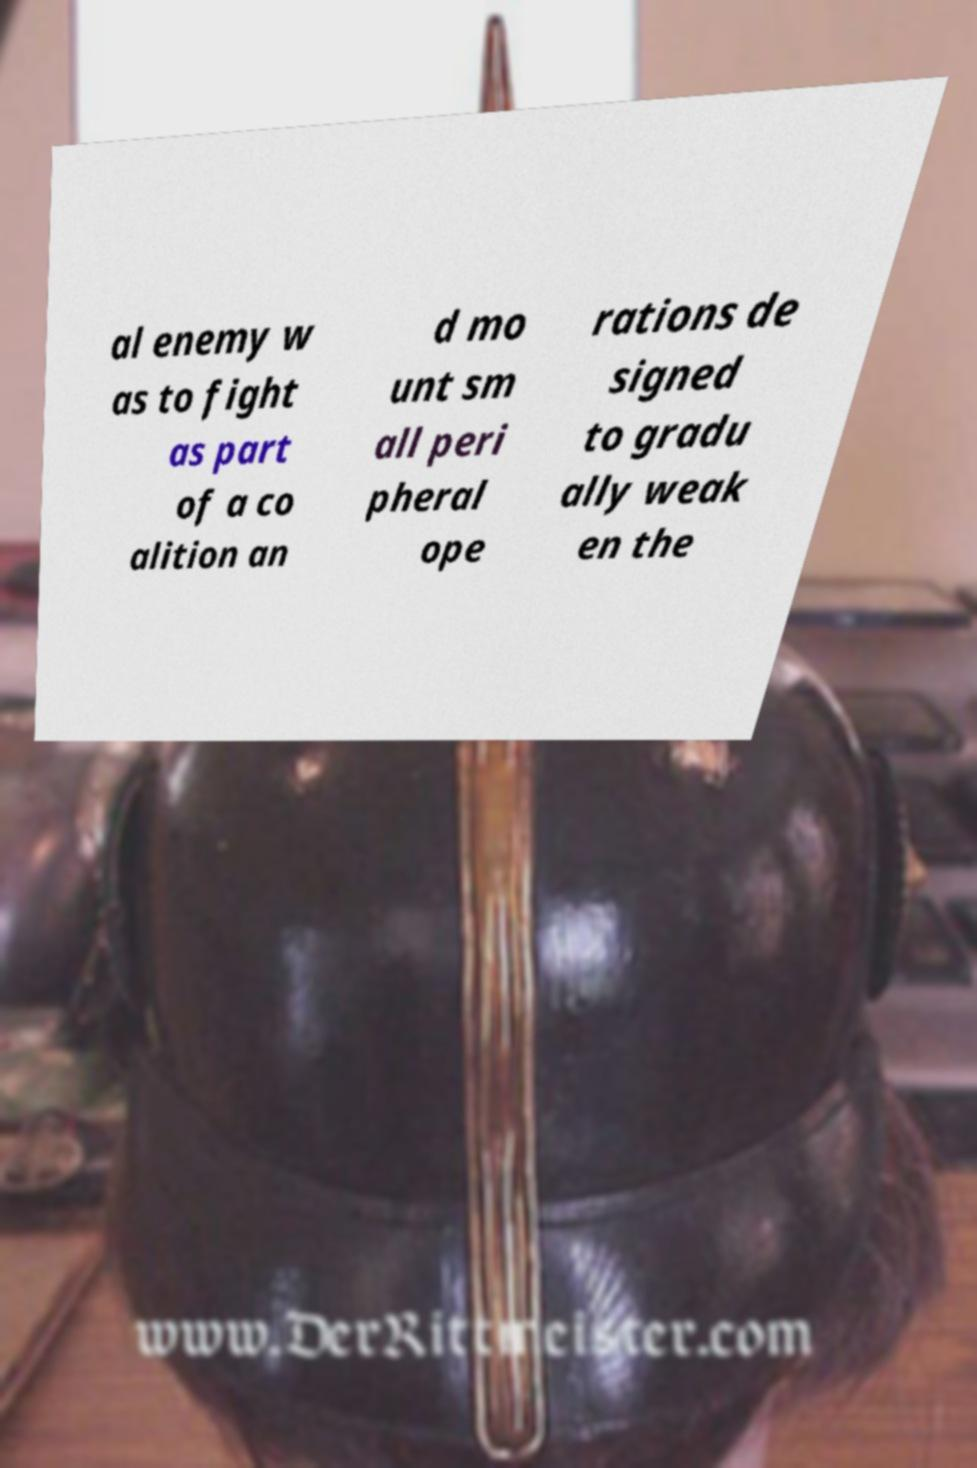There's text embedded in this image that I need extracted. Can you transcribe it verbatim? al enemy w as to fight as part of a co alition an d mo unt sm all peri pheral ope rations de signed to gradu ally weak en the 